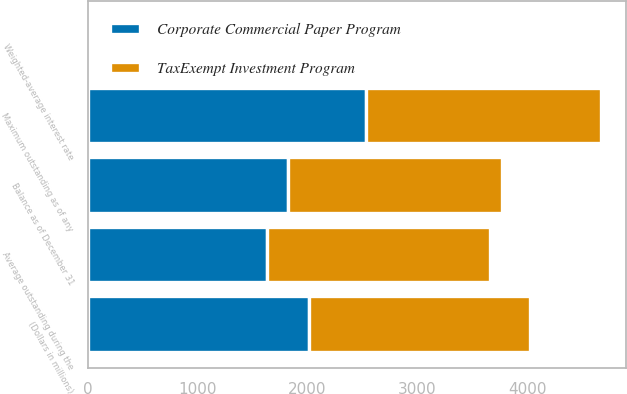Convert chart. <chart><loc_0><loc_0><loc_500><loc_500><stacked_bar_chart><ecel><fcel>(Dollars in millions)<fcel>Balance as of December 31<fcel>Maximum outstanding as of any<fcel>Average outstanding during the<fcel>Weighted-average interest rate<nl><fcel>TaxExempt Investment Program<fcel>2013<fcel>1948<fcel>2135<fcel>2030<fcel>0.13<nl><fcel>Corporate Commercial Paper Program<fcel>2013<fcel>1819<fcel>2535<fcel>1632<fcel>0.18<nl></chart> 